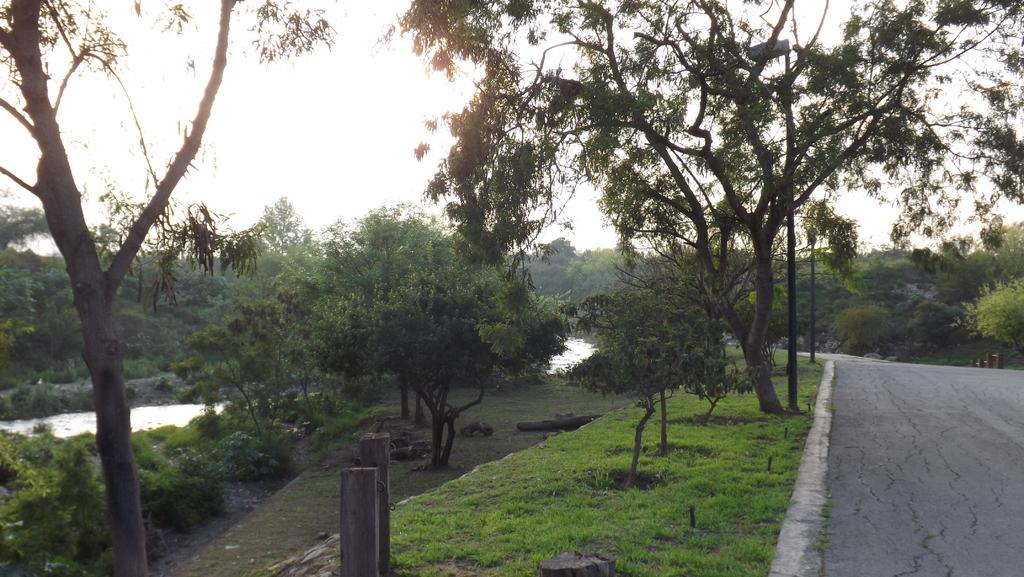What can be seen in the background of the image? The sky is visible in the background of the image. What type of vegetation is present in the image? There are trees in the image, and green grass is also present. What are the wooden poles used for in the image? The purpose of the wooden poles is not specified, but they are visible in the image. What is the body of water in the image? There is water in the image, but its specific type or purpose is not mentioned. What is located on the right side of the image? There is a road on the right side of the image. How does the digestion process work for the trees in the image? The image does not depict a digestion process for the trees, as trees do not have a digestive system like animals. What type of ring is visible on the wooden poles in the image? There are no rings visible on the wooden poles in the image. 